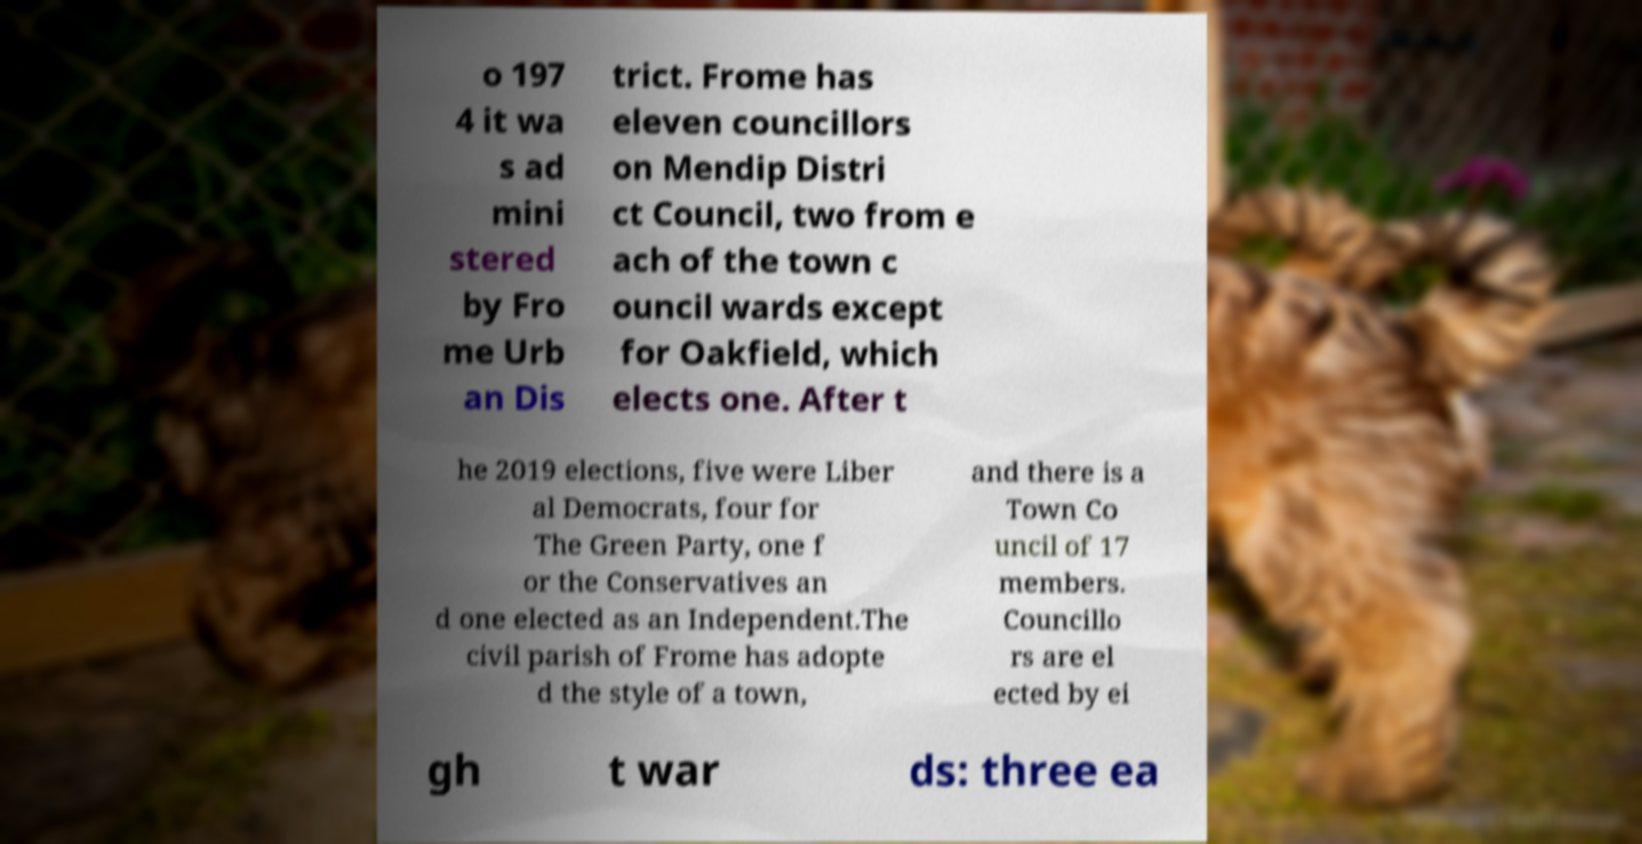I need the written content from this picture converted into text. Can you do that? o 197 4 it wa s ad mini stered by Fro me Urb an Dis trict. Frome has eleven councillors on Mendip Distri ct Council, two from e ach of the town c ouncil wards except for Oakfield, which elects one. After t he 2019 elections, five were Liber al Democrats, four for The Green Party, one f or the Conservatives an d one elected as an Independent.The civil parish of Frome has adopte d the style of a town, and there is a Town Co uncil of 17 members. Councillo rs are el ected by ei gh t war ds: three ea 